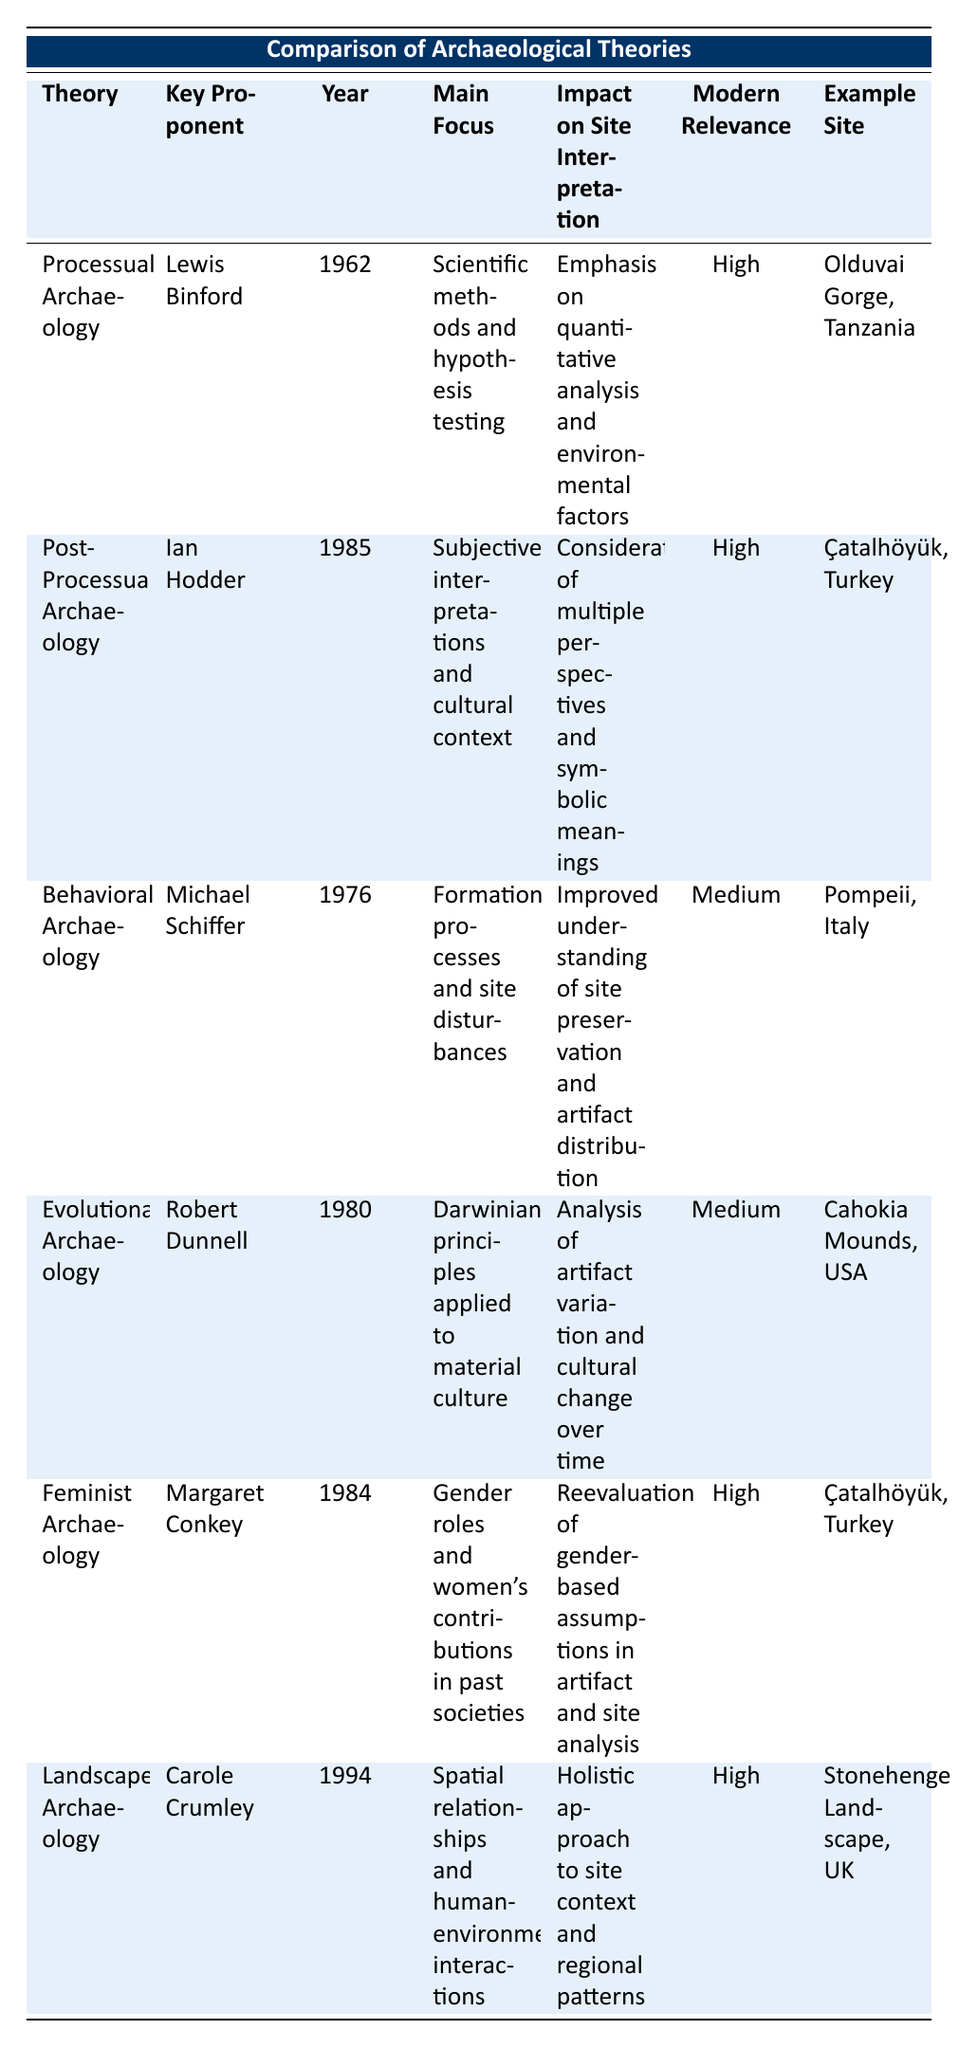What year was Processual Archaeology introduced? The table lists "Processual Archaeology" in the first row, and the "Year Introduced" column for this theory contains the value "1962."
Answer: 1962 Who is the key proponent of Feminist Archaeology? In the table, Feminist Archaeology is listed with a "Key Proponent" of "Margaret Conkey."
Answer: Margaret Conkey Which theories have high modern relevance? The "Modern Relevance" column highlights those theories with "High." These are Processual Archaeology, Post-Processual Archaeology, Feminist Archaeology, and Landscape Archaeology.
Answer: Processual, Post-Processual, Feminist, Landscape What is the main focus of Behavioral Archaeology? Looking at the row for Behavioral Archaeology, the "Main Focus" column clearly states "Formation processes and site disturbances."
Answer: Formation processes and site disturbances Which site is associated with the Post-Processual Archaeology theory? In the "Example Site" column, the row for Post-Processual Archaeology identifies "Çatalhöyük, Turkey" as its example site.
Answer: Çatalhöyük, Turkey Is the Impact on Site Interpretation for Evolutionary Archaeology medium? The "Impact on Site Interpretation" for Evolutionary Archaeology in the table is listed as "Medium," thus confirming the statement is true.
Answer: Yes How many theories emphasize qualitative analysis rather than quantitative analysis? The theories that emphasize qualitative analysis based on the "Main Focus" column include Post-Processual Archaeology and Feminist Archaeology. Therefore, there are 2 theories.
Answer: 2 What is the difference in modern relevance ratings between Behavioral Archaeology and Landscape Archaeology? Behavioral Archaeology has a modern relevance of "Medium," while Landscape Archaeology has "High." This shows a difference of one level in relevance.
Answer: 1 level Which archaeological theory focuses on spatial relationships? The table indicates that Landscape Archaeology has a main focus on "Spatial relationships and human-environment interactions."
Answer: Landscape Archaeology What year was Behavioral Archaeology introduced compared to Feminist Archaeology? The table shows that Behavioral Archaeology was introduced in 1976 and Feminist Archaeology in 1984. The difference in years is calculated as 1984 - 1976, which equals 8 years.
Answer: 8 years 